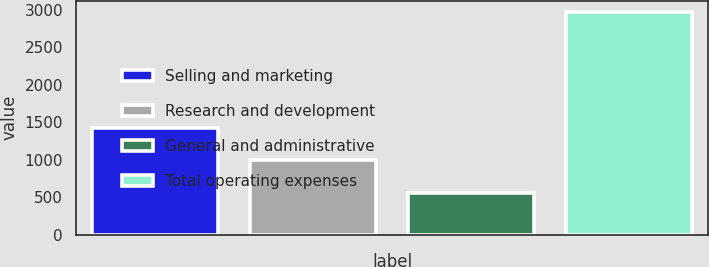<chart> <loc_0><loc_0><loc_500><loc_500><bar_chart><fcel>Selling and marketing<fcel>Research and development<fcel>General and administrative<fcel>Total operating expenses<nl><fcel>1420<fcel>998<fcel>553<fcel>2973<nl></chart> 